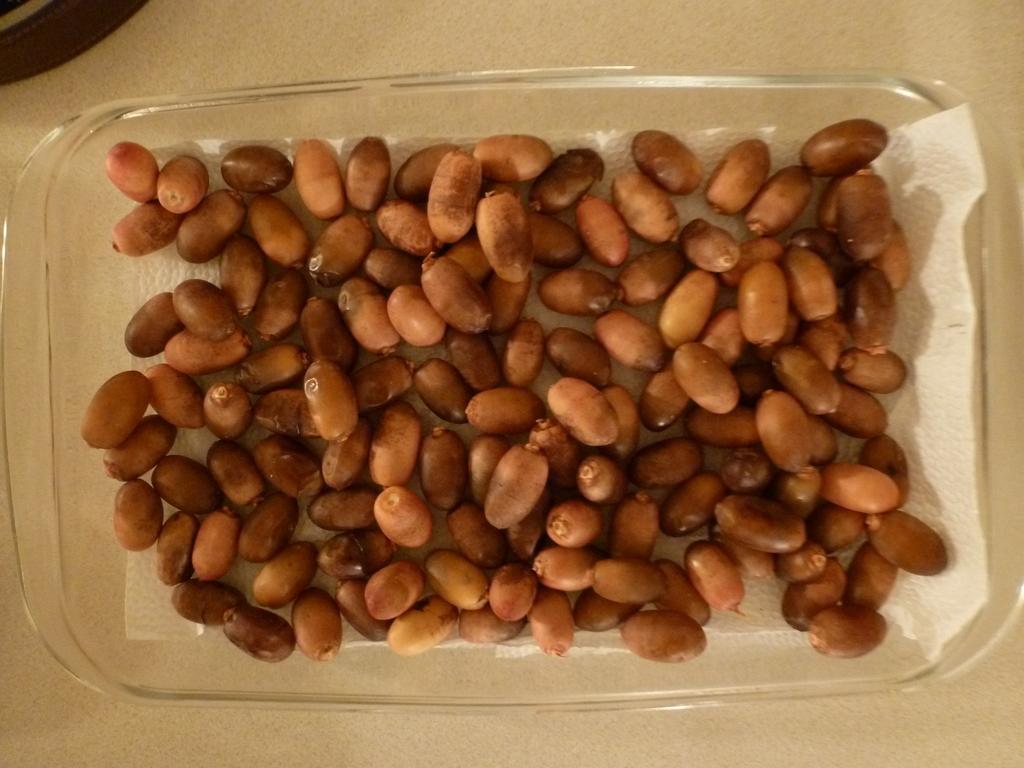Please provide a concise description of this image. In this image I can see it looks like red dates in a transparent plate. 